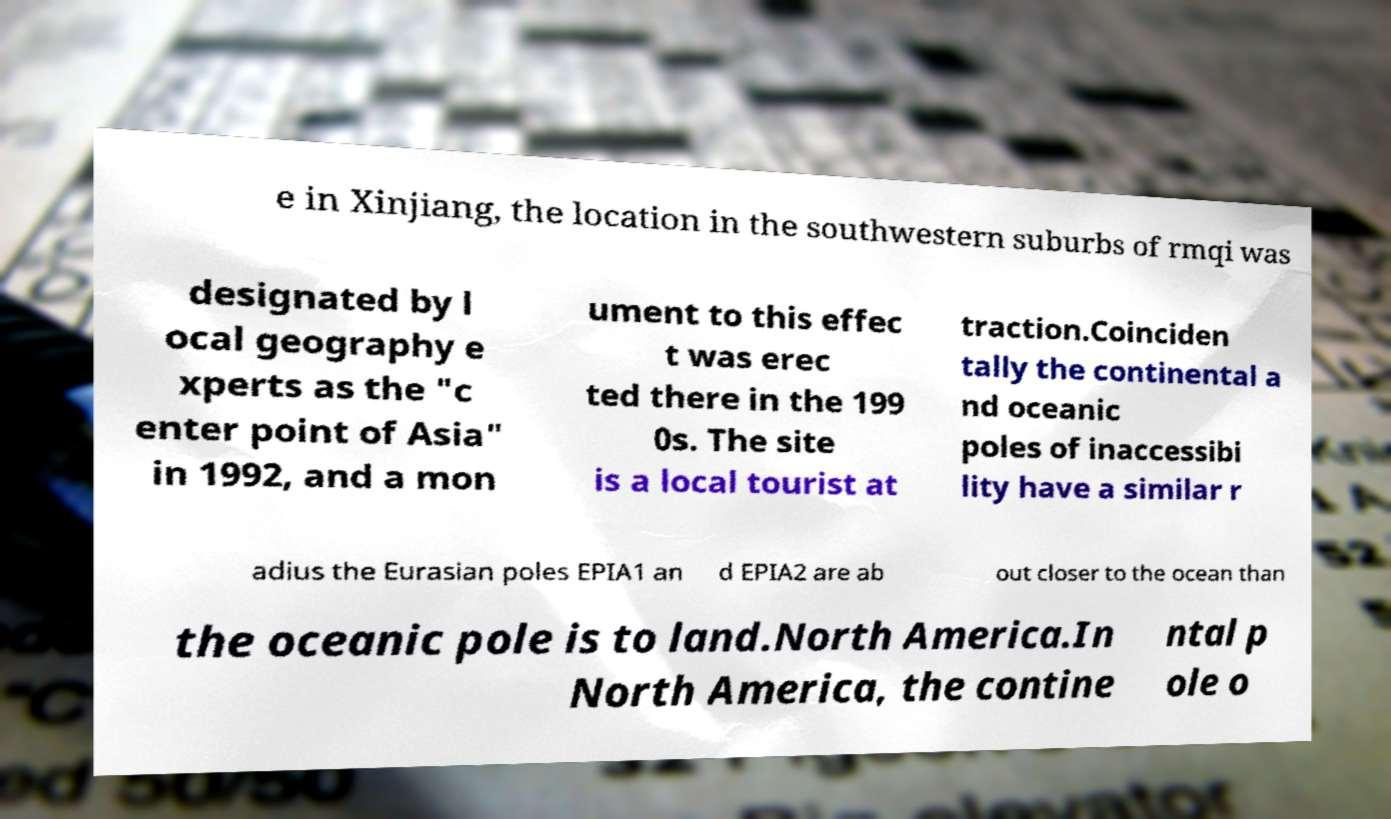Could you assist in decoding the text presented in this image and type it out clearly? e in Xinjiang, the location in the southwestern suburbs of rmqi was designated by l ocal geography e xperts as the "c enter point of Asia" in 1992, and a mon ument to this effec t was erec ted there in the 199 0s. The site is a local tourist at traction.Coinciden tally the continental a nd oceanic poles of inaccessibi lity have a similar r adius the Eurasian poles EPIA1 an d EPIA2 are ab out closer to the ocean than the oceanic pole is to land.North America.In North America, the contine ntal p ole o 